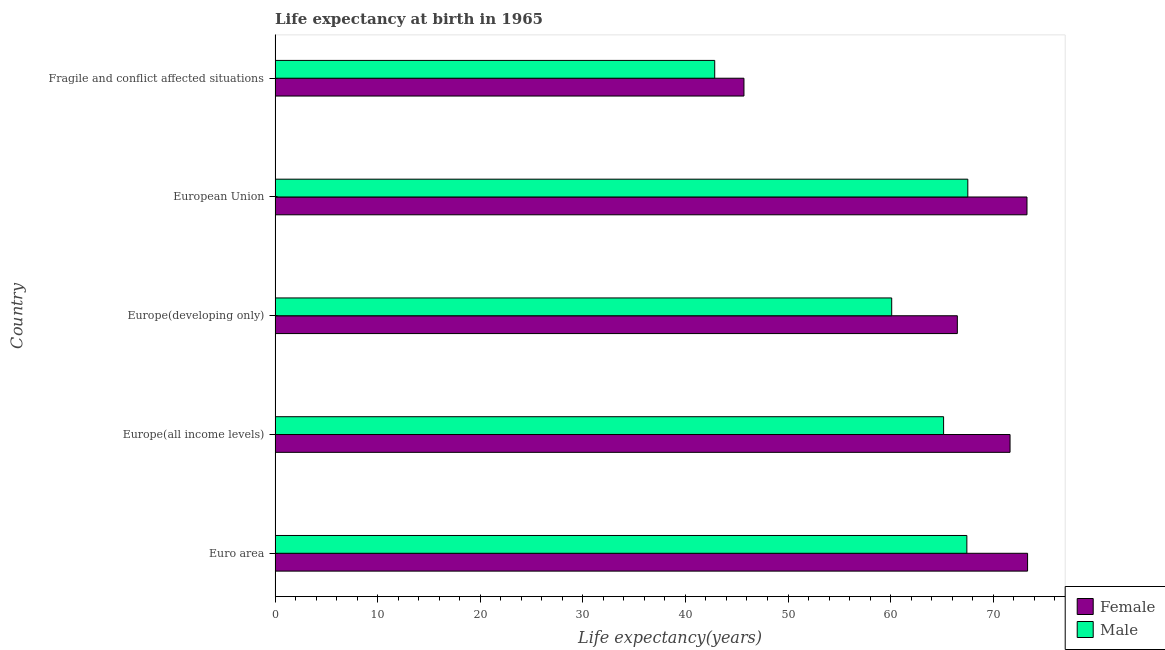How many different coloured bars are there?
Your answer should be very brief. 2. How many groups of bars are there?
Offer a very short reply. 5. Are the number of bars per tick equal to the number of legend labels?
Provide a short and direct response. Yes. Are the number of bars on each tick of the Y-axis equal?
Ensure brevity in your answer.  Yes. How many bars are there on the 1st tick from the top?
Offer a terse response. 2. What is the label of the 5th group of bars from the top?
Offer a very short reply. Euro area. What is the life expectancy(female) in Europe(developing only)?
Provide a succinct answer. 66.51. Across all countries, what is the maximum life expectancy(female)?
Ensure brevity in your answer.  73.35. Across all countries, what is the minimum life expectancy(male)?
Your answer should be compact. 42.86. In which country was the life expectancy(female) minimum?
Offer a terse response. Fragile and conflict affected situations. What is the total life expectancy(female) in the graph?
Offer a terse response. 330.5. What is the difference between the life expectancy(female) in Euro area and that in Europe(developing only)?
Provide a short and direct response. 6.85. What is the difference between the life expectancy(male) in Europe(developing only) and the life expectancy(female) in European Union?
Offer a terse response. -13.19. What is the average life expectancy(female) per country?
Offer a very short reply. 66.1. What is the difference between the life expectancy(male) and life expectancy(female) in Europe(all income levels)?
Give a very brief answer. -6.48. What is the ratio of the life expectancy(female) in Europe(all income levels) to that in Fragile and conflict affected situations?
Offer a terse response. 1.57. Is the difference between the life expectancy(female) in Europe(all income levels) and Fragile and conflict affected situations greater than the difference between the life expectancy(male) in Europe(all income levels) and Fragile and conflict affected situations?
Your answer should be compact. Yes. What is the difference between the highest and the second highest life expectancy(female)?
Your answer should be compact. 0.06. What is the difference between the highest and the lowest life expectancy(female)?
Your answer should be very brief. 27.65. What does the 1st bar from the top in Fragile and conflict affected situations represents?
Provide a succinct answer. Male. How many countries are there in the graph?
Give a very brief answer. 5. Does the graph contain any zero values?
Your response must be concise. No. What is the title of the graph?
Provide a succinct answer. Life expectancy at birth in 1965. What is the label or title of the X-axis?
Ensure brevity in your answer.  Life expectancy(years). What is the label or title of the Y-axis?
Offer a terse response. Country. What is the Life expectancy(years) in Female in Euro area?
Give a very brief answer. 73.35. What is the Life expectancy(years) in Male in Euro area?
Your answer should be very brief. 67.43. What is the Life expectancy(years) in Female in Europe(all income levels)?
Offer a very short reply. 71.64. What is the Life expectancy(years) of Male in Europe(all income levels)?
Your response must be concise. 65.17. What is the Life expectancy(years) of Female in Europe(developing only)?
Your answer should be very brief. 66.51. What is the Life expectancy(years) of Male in Europe(developing only)?
Ensure brevity in your answer.  60.11. What is the Life expectancy(years) of Female in European Union?
Your answer should be compact. 73.29. What is the Life expectancy(years) of Male in European Union?
Make the answer very short. 67.53. What is the Life expectancy(years) of Female in Fragile and conflict affected situations?
Provide a succinct answer. 45.7. What is the Life expectancy(years) of Male in Fragile and conflict affected situations?
Provide a short and direct response. 42.86. Across all countries, what is the maximum Life expectancy(years) in Female?
Your response must be concise. 73.35. Across all countries, what is the maximum Life expectancy(years) of Male?
Your answer should be compact. 67.53. Across all countries, what is the minimum Life expectancy(years) in Female?
Offer a terse response. 45.7. Across all countries, what is the minimum Life expectancy(years) in Male?
Offer a terse response. 42.86. What is the total Life expectancy(years) of Female in the graph?
Provide a succinct answer. 330.5. What is the total Life expectancy(years) of Male in the graph?
Ensure brevity in your answer.  303.09. What is the difference between the Life expectancy(years) in Female in Euro area and that in Europe(all income levels)?
Ensure brevity in your answer.  1.71. What is the difference between the Life expectancy(years) of Male in Euro area and that in Europe(all income levels)?
Offer a very short reply. 2.27. What is the difference between the Life expectancy(years) in Female in Euro area and that in Europe(developing only)?
Offer a terse response. 6.85. What is the difference between the Life expectancy(years) of Male in Euro area and that in Europe(developing only)?
Provide a succinct answer. 7.33. What is the difference between the Life expectancy(years) in Female in Euro area and that in European Union?
Your answer should be compact. 0.06. What is the difference between the Life expectancy(years) of Male in Euro area and that in European Union?
Give a very brief answer. -0.09. What is the difference between the Life expectancy(years) in Female in Euro area and that in Fragile and conflict affected situations?
Give a very brief answer. 27.65. What is the difference between the Life expectancy(years) of Male in Euro area and that in Fragile and conflict affected situations?
Make the answer very short. 24.58. What is the difference between the Life expectancy(years) in Female in Europe(all income levels) and that in Europe(developing only)?
Your response must be concise. 5.14. What is the difference between the Life expectancy(years) in Male in Europe(all income levels) and that in Europe(developing only)?
Your response must be concise. 5.06. What is the difference between the Life expectancy(years) of Female in Europe(all income levels) and that in European Union?
Make the answer very short. -1.65. What is the difference between the Life expectancy(years) in Male in Europe(all income levels) and that in European Union?
Your answer should be very brief. -2.36. What is the difference between the Life expectancy(years) of Female in Europe(all income levels) and that in Fragile and conflict affected situations?
Give a very brief answer. 25.94. What is the difference between the Life expectancy(years) of Male in Europe(all income levels) and that in Fragile and conflict affected situations?
Your answer should be compact. 22.31. What is the difference between the Life expectancy(years) in Female in Europe(developing only) and that in European Union?
Ensure brevity in your answer.  -6.79. What is the difference between the Life expectancy(years) in Male in Europe(developing only) and that in European Union?
Offer a terse response. -7.42. What is the difference between the Life expectancy(years) in Female in Europe(developing only) and that in Fragile and conflict affected situations?
Offer a very short reply. 20.8. What is the difference between the Life expectancy(years) in Male in Europe(developing only) and that in Fragile and conflict affected situations?
Keep it short and to the point. 17.25. What is the difference between the Life expectancy(years) of Female in European Union and that in Fragile and conflict affected situations?
Offer a very short reply. 27.59. What is the difference between the Life expectancy(years) in Male in European Union and that in Fragile and conflict affected situations?
Provide a short and direct response. 24.67. What is the difference between the Life expectancy(years) of Female in Euro area and the Life expectancy(years) of Male in Europe(all income levels)?
Give a very brief answer. 8.19. What is the difference between the Life expectancy(years) in Female in Euro area and the Life expectancy(years) in Male in Europe(developing only)?
Offer a very short reply. 13.24. What is the difference between the Life expectancy(years) in Female in Euro area and the Life expectancy(years) in Male in European Union?
Offer a very short reply. 5.83. What is the difference between the Life expectancy(years) in Female in Euro area and the Life expectancy(years) in Male in Fragile and conflict affected situations?
Make the answer very short. 30.5. What is the difference between the Life expectancy(years) in Female in Europe(all income levels) and the Life expectancy(years) in Male in Europe(developing only)?
Offer a terse response. 11.54. What is the difference between the Life expectancy(years) of Female in Europe(all income levels) and the Life expectancy(years) of Male in European Union?
Provide a short and direct response. 4.12. What is the difference between the Life expectancy(years) of Female in Europe(all income levels) and the Life expectancy(years) of Male in Fragile and conflict affected situations?
Your answer should be very brief. 28.79. What is the difference between the Life expectancy(years) of Female in Europe(developing only) and the Life expectancy(years) of Male in European Union?
Your response must be concise. -1.02. What is the difference between the Life expectancy(years) of Female in Europe(developing only) and the Life expectancy(years) of Male in Fragile and conflict affected situations?
Ensure brevity in your answer.  23.65. What is the difference between the Life expectancy(years) in Female in European Union and the Life expectancy(years) in Male in Fragile and conflict affected situations?
Your answer should be very brief. 30.44. What is the average Life expectancy(years) of Female per country?
Provide a short and direct response. 66.1. What is the average Life expectancy(years) of Male per country?
Offer a very short reply. 60.62. What is the difference between the Life expectancy(years) in Female and Life expectancy(years) in Male in Euro area?
Keep it short and to the point. 5.92. What is the difference between the Life expectancy(years) in Female and Life expectancy(years) in Male in Europe(all income levels)?
Keep it short and to the point. 6.48. What is the difference between the Life expectancy(years) of Female and Life expectancy(years) of Male in Europe(developing only)?
Offer a terse response. 6.4. What is the difference between the Life expectancy(years) in Female and Life expectancy(years) in Male in European Union?
Offer a very short reply. 5.77. What is the difference between the Life expectancy(years) of Female and Life expectancy(years) of Male in Fragile and conflict affected situations?
Provide a succinct answer. 2.85. What is the ratio of the Life expectancy(years) of Female in Euro area to that in Europe(all income levels)?
Make the answer very short. 1.02. What is the ratio of the Life expectancy(years) in Male in Euro area to that in Europe(all income levels)?
Provide a short and direct response. 1.03. What is the ratio of the Life expectancy(years) in Female in Euro area to that in Europe(developing only)?
Offer a very short reply. 1.1. What is the ratio of the Life expectancy(years) in Male in Euro area to that in Europe(developing only)?
Your response must be concise. 1.12. What is the ratio of the Life expectancy(years) of Female in Euro area to that in European Union?
Your answer should be very brief. 1. What is the ratio of the Life expectancy(years) of Female in Euro area to that in Fragile and conflict affected situations?
Provide a succinct answer. 1.6. What is the ratio of the Life expectancy(years) of Male in Euro area to that in Fragile and conflict affected situations?
Your answer should be compact. 1.57. What is the ratio of the Life expectancy(years) of Female in Europe(all income levels) to that in Europe(developing only)?
Provide a short and direct response. 1.08. What is the ratio of the Life expectancy(years) in Male in Europe(all income levels) to that in Europe(developing only)?
Your answer should be compact. 1.08. What is the ratio of the Life expectancy(years) of Female in Europe(all income levels) to that in European Union?
Provide a succinct answer. 0.98. What is the ratio of the Life expectancy(years) in Male in Europe(all income levels) to that in European Union?
Keep it short and to the point. 0.96. What is the ratio of the Life expectancy(years) of Female in Europe(all income levels) to that in Fragile and conflict affected situations?
Give a very brief answer. 1.57. What is the ratio of the Life expectancy(years) in Male in Europe(all income levels) to that in Fragile and conflict affected situations?
Provide a succinct answer. 1.52. What is the ratio of the Life expectancy(years) of Female in Europe(developing only) to that in European Union?
Give a very brief answer. 0.91. What is the ratio of the Life expectancy(years) in Male in Europe(developing only) to that in European Union?
Keep it short and to the point. 0.89. What is the ratio of the Life expectancy(years) of Female in Europe(developing only) to that in Fragile and conflict affected situations?
Offer a very short reply. 1.46. What is the ratio of the Life expectancy(years) in Male in Europe(developing only) to that in Fragile and conflict affected situations?
Offer a terse response. 1.4. What is the ratio of the Life expectancy(years) in Female in European Union to that in Fragile and conflict affected situations?
Your response must be concise. 1.6. What is the ratio of the Life expectancy(years) in Male in European Union to that in Fragile and conflict affected situations?
Make the answer very short. 1.58. What is the difference between the highest and the second highest Life expectancy(years) in Female?
Keep it short and to the point. 0.06. What is the difference between the highest and the second highest Life expectancy(years) of Male?
Offer a very short reply. 0.09. What is the difference between the highest and the lowest Life expectancy(years) of Female?
Give a very brief answer. 27.65. What is the difference between the highest and the lowest Life expectancy(years) of Male?
Your answer should be compact. 24.67. 